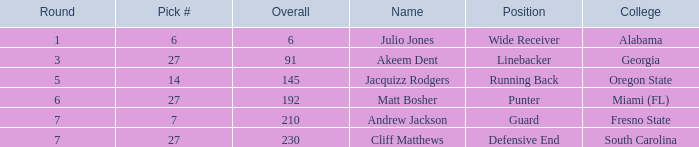Which name had more than 5 rounds and was a defensive end? Cliff Matthews. 